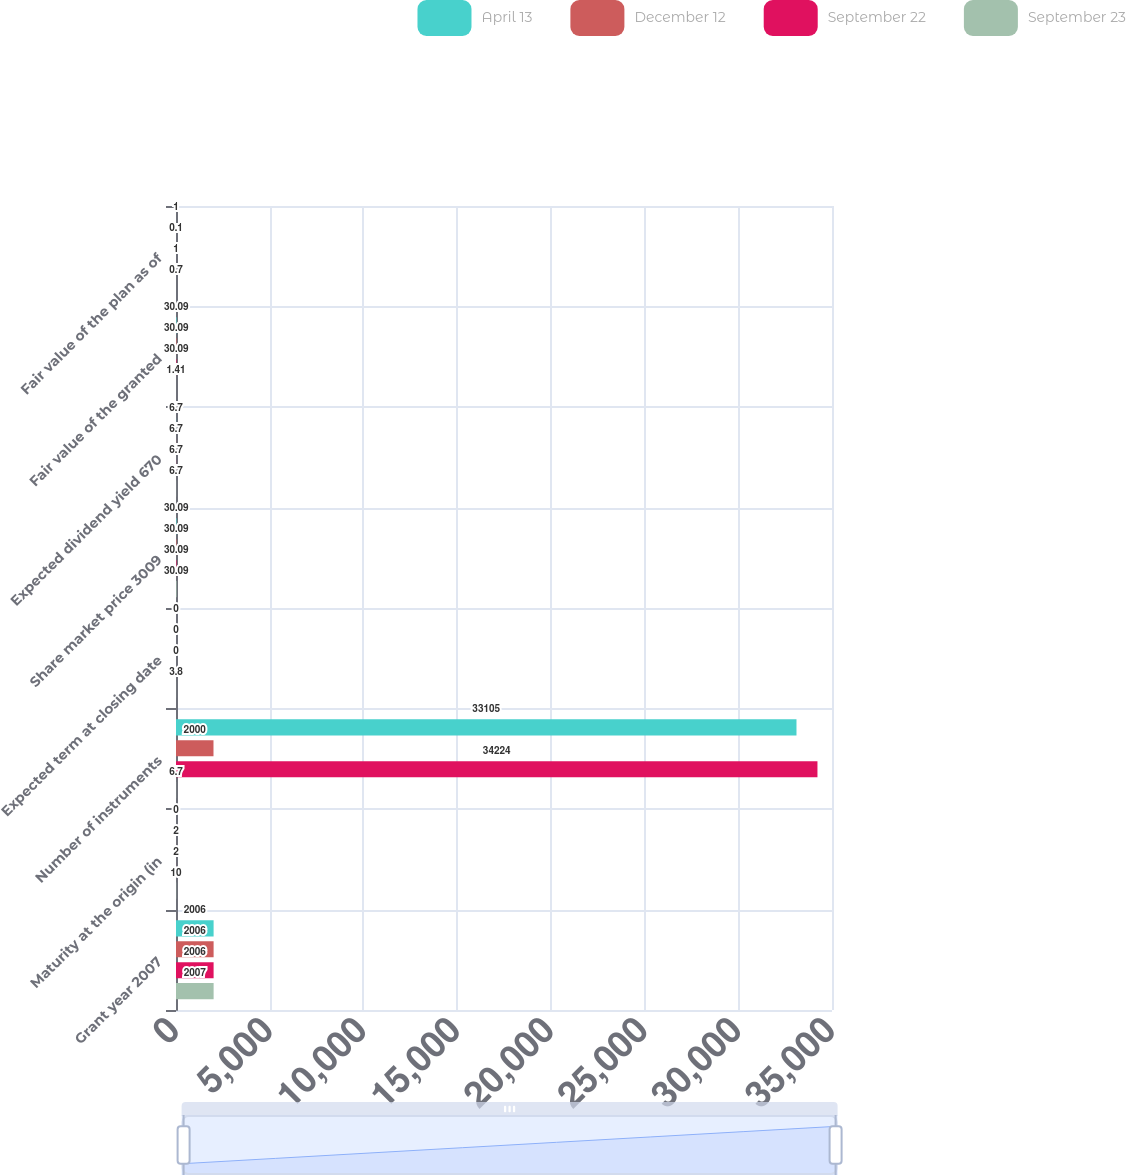<chart> <loc_0><loc_0><loc_500><loc_500><stacked_bar_chart><ecel><fcel>Grant year 2007<fcel>Maturity at the origin (in<fcel>Number of instruments<fcel>Expected term at closing date<fcel>Share market price 3009<fcel>Expected dividend yield 670<fcel>Fair value of the granted<fcel>Fair value of the plan as of<nl><fcel>April 13<fcel>2006<fcel>0<fcel>33105<fcel>0<fcel>30.09<fcel>6.7<fcel>30.09<fcel>1<nl><fcel>December 12<fcel>2006<fcel>2<fcel>2000<fcel>0<fcel>30.09<fcel>6.7<fcel>30.09<fcel>0.1<nl><fcel>September 22<fcel>2006<fcel>2<fcel>34224<fcel>0<fcel>30.09<fcel>6.7<fcel>30.09<fcel>1<nl><fcel>September 23<fcel>2007<fcel>10<fcel>6.7<fcel>3.8<fcel>30.09<fcel>6.7<fcel>1.41<fcel>0.7<nl></chart> 